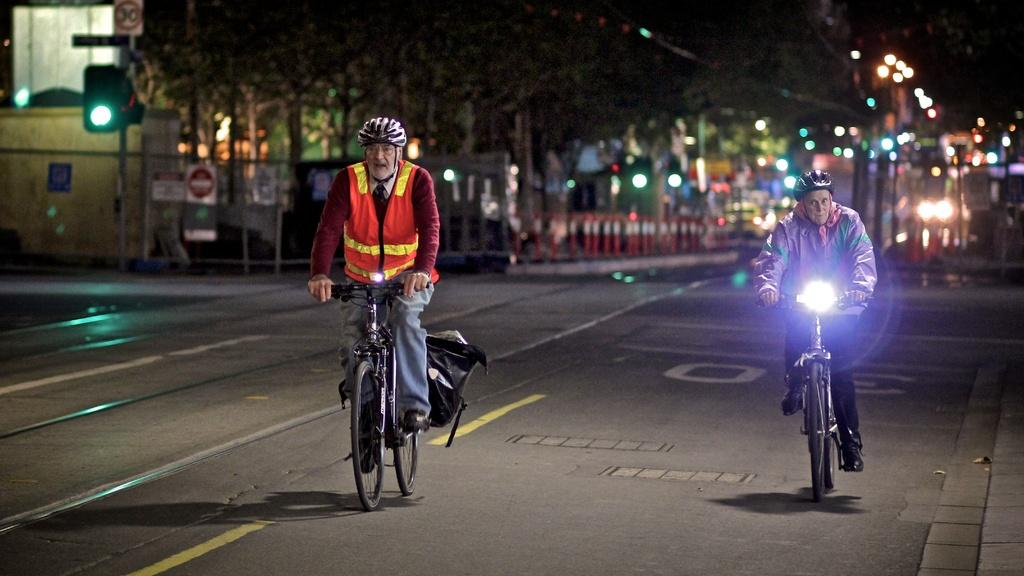What are the two people in the image doing? The two people in the image are riding bicycles. What safety precaution are the people taking while riding their bicycles? Both people are wearing helmets. What can be seen in the background of the image? There is a signal light and trees in the background of the image. What type of cork can be seen on the bicycle wheels in the image? There is no cork present on the bicycle wheels in the image. How many hooks are attached to the bicycles in the image? There are no hooks visible on the bicycles in the image. 